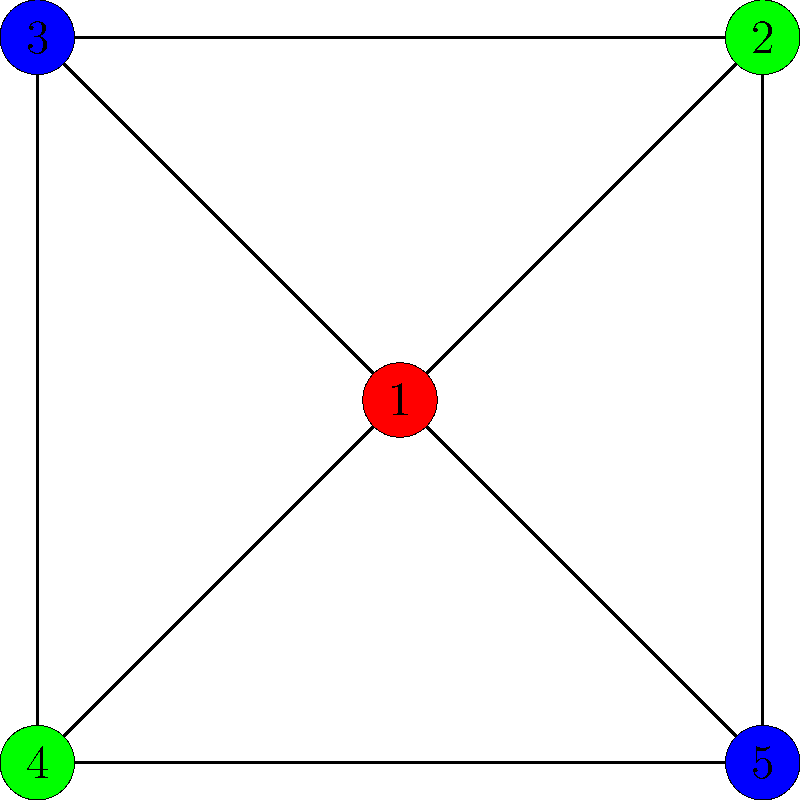In a complex ensemble cast for a new film project, you need to map out character relationships using graph coloring. The graph represents five main characters, with edges connecting characters who have significant interactions. What is the chromatic number of this graph, and how might this information be useful in developing the ensemble's dynamics? To solve this problem, let's approach it step-by-step:

1. Understanding graph coloring:
   - Each vertex (character) must be colored such that no two adjacent vertices (connected characters) have the same color.
   - The chromatic number is the minimum number of colors needed to color the graph properly.

2. Analyzing the graph:
   - We have 5 vertices (characters) numbered 1 to 5.
   - Character 1 is connected to all other characters.
   - Characters 2 and 4 are not directly connected.
   - Characters 3 and 5 are not directly connected.

3. Determining the chromatic number:
   - Start with character 1 (center). It needs a unique color (red).
   - Characters 2 and 4 can share a color (green) as they're not connected.
   - Characters 3 and 5 can share another color (blue) as they're not connected.
   - This coloring satisfies all constraints with 3 colors.
   - We can't use fewer than 3 colors because character 1 is connected to all others.

4. The chromatic number is therefore 3.

5. Usefulness in developing ensemble dynamics:
   - The three color groups represent potential alliances or conflicting relationships.
   - Characters of the same color (2&4, 3&5) might have similar traits or storylines.
   - Character 1 (unique color) could be a central figure connecting all storylines.
   - This structure ensures complex interactions while maintaining clear relationship distinctions.
   - It can guide scene planning, ensuring varied character combinations and balanced screen time.

This graph coloring approach aligns with a naturalistic acting style by providing a clear structure for character relationships, allowing for nuanced performances within a well-defined ensemble dynamic.
Answer: Chromatic number: 3. Useful for structuring character relationships and storylines. 